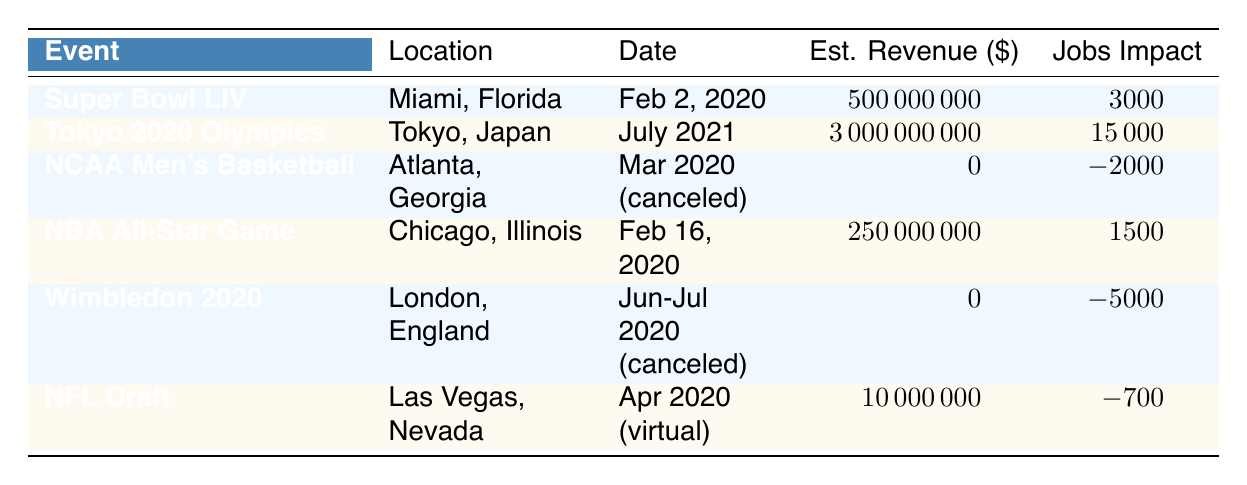What is the estimated revenue from Super Bowl LIV? The table lists the estimated revenue for Super Bowl LIV as $500,000,000.
Answer: $500,000,000 How many jobs were created by the NBA All-Star Game? The table states that the NBA All-Star Game created 1,500 jobs.
Answer: 1,500 What was the total local business boost from both Super Bowl LIV and the NBA All-Star Game? Super Bowl LIV had a local business boost of $250,000,000 and the NBA All-Star Game had a boost of $80,000,000. Adding these gives $250,000,000 + $80,000,000 = $330,000,000.
Answer: $330,000,000 Was the NCAA Men's Basketball Tournament successful in terms of estimated revenue? The table shows the estimated revenue for the NCAA Men's Basketball Tournament as $0, indicating it was not successful financially.
Answer: No What is the net job impact from the NCAA Men's Basketball Tournament and Wimbledon 2020? The NCAA Men's Basketball Tournament resulted in a loss of 2,000 jobs, and Wimbledon 2020 resulted in a loss of 5,000 jobs. Adding these losses gives a total job impact of -2,000 + -5,000 = -7,000.
Answer: -7,000 Which event had the highest estimated revenue? Looking at the table, the Tokyo 2020 Olympics has the highest expected revenue of $3,000,000,000.
Answer: Tokyo 2020 Olympics If the NFL Draft generated an estimated revenue of $10,000,000, how does this compare to the Super Bowl LIV's revenue? The NFL Draft generated $10,000,000, while Super Bowl LIV generated $500,000,000. This means Super Bowl LIV's revenue is significantly higher by $500,000,000 - $10,000,000 = $490,000,000.
Answer: $490,000,000 What was the total number of jobs lost due to events that were canceled in 2020? NCAA Men's Basketball Tournament lost 2,000 jobs, and Wimbledon 2020 lost 5,000 jobs. Adding the losses gives -2,000 + -5,000 = -7,000 jobs.
Answer: -7,000 jobs How does the local business boost from the Super Bowl LIV compare to that of the NFL Draft? The local business boost for Super Bowl LIV is $250,000,000, while for the NFL Draft, it is a loss of $5,000,000. Comparing these, Super Bowl LIV significantly exceeded the NFL Draft by $250,000,000 - (-$5,000,000) = $255,000,000.
Answer: $255,000,000 What was the expected total revenue impact from events held in February 2020? The events in February 2020 are Super Bowl LIV ($500,000,000) and the NBA All-Star Game ($250,000,000). Combining these gives $500,000,000 + $250,000,000 = $750,000,000 in expected revenue.
Answer: $750,000,000 